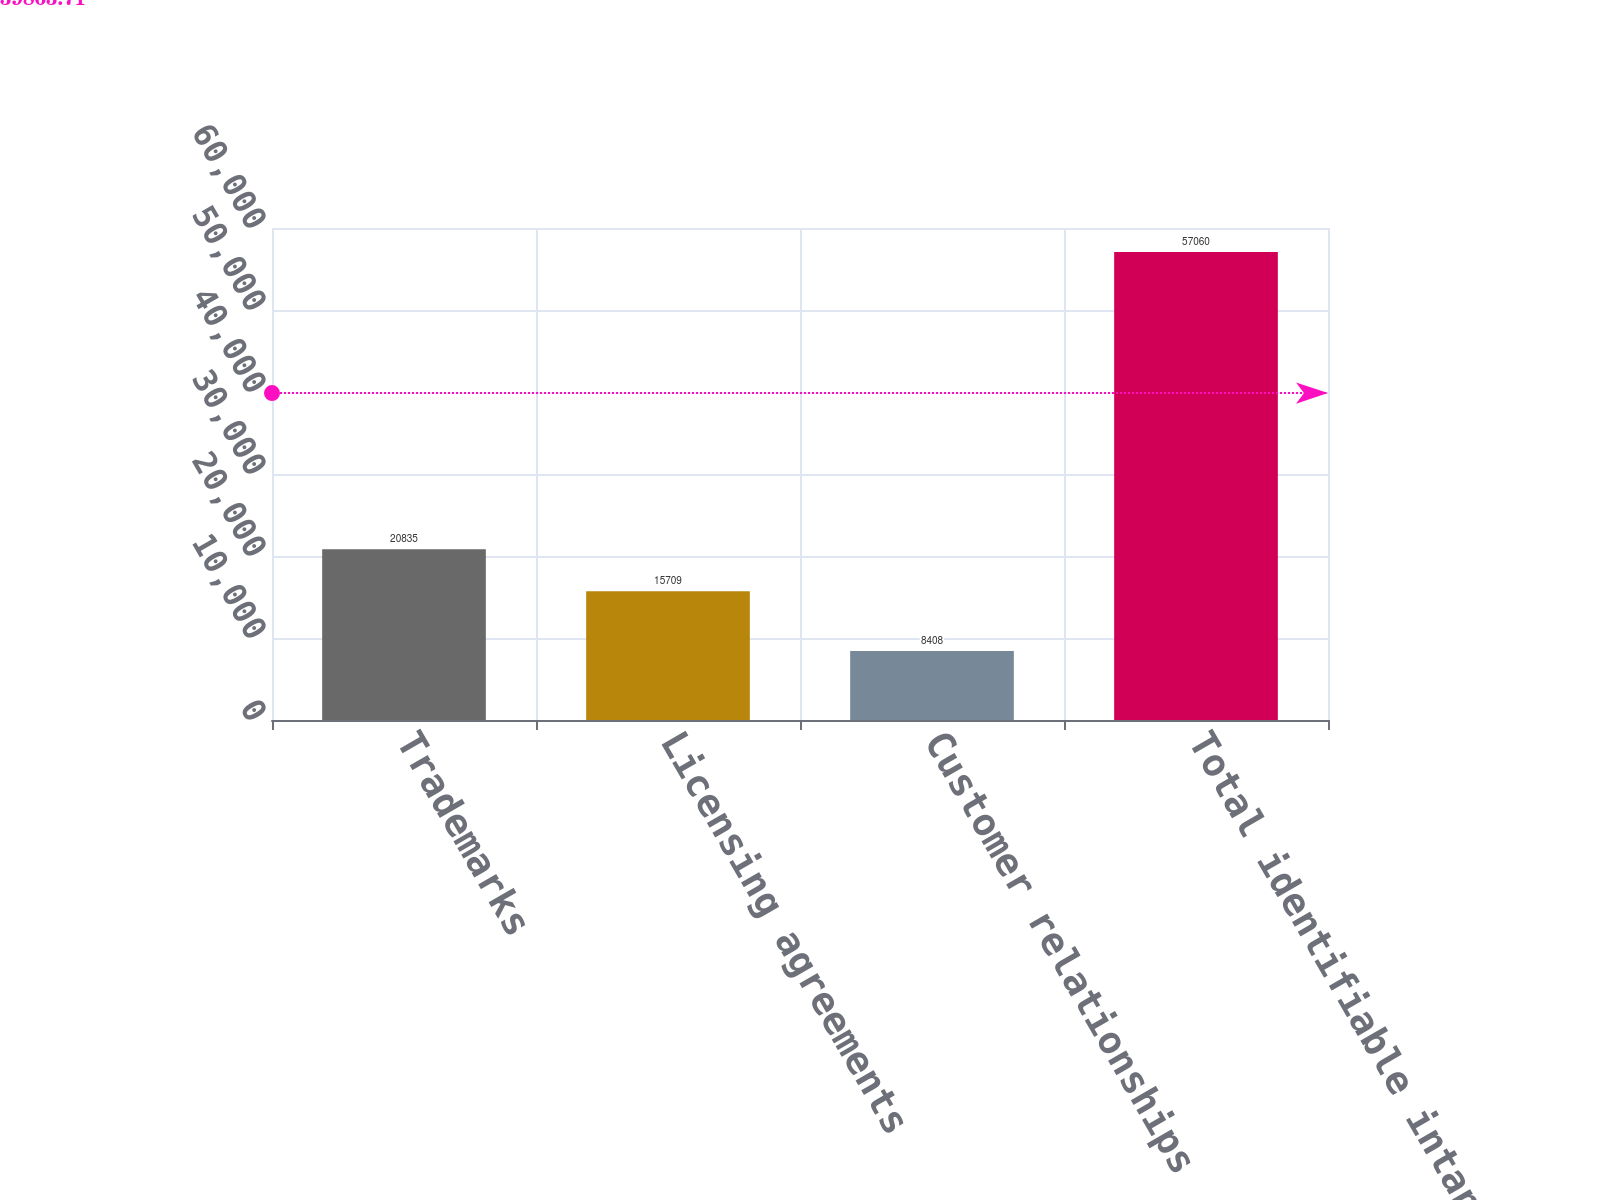<chart> <loc_0><loc_0><loc_500><loc_500><bar_chart><fcel>Trademarks<fcel>Licensing agreements<fcel>Customer relationships<fcel>Total identifiable intangible<nl><fcel>20835<fcel>15709<fcel>8408<fcel>57060<nl></chart> 